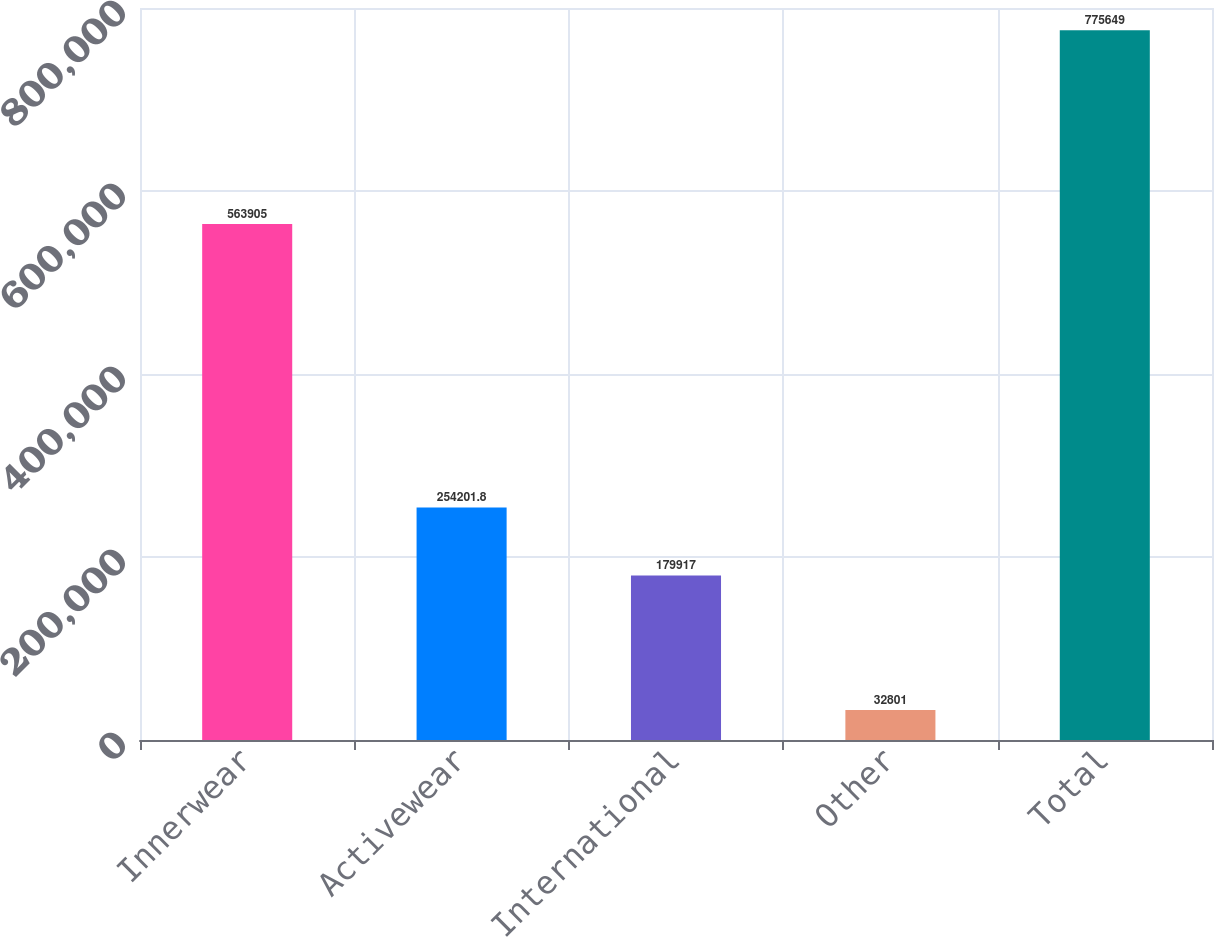Convert chart to OTSL. <chart><loc_0><loc_0><loc_500><loc_500><bar_chart><fcel>Innerwear<fcel>Activewear<fcel>International<fcel>Other<fcel>Total<nl><fcel>563905<fcel>254202<fcel>179917<fcel>32801<fcel>775649<nl></chart> 